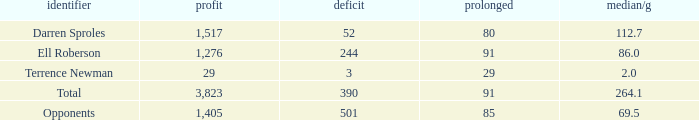When the player gained below 1,405 yards and lost over 390 yards, what's the sum of the long yards? None. 